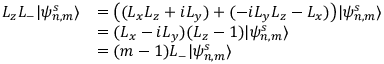<formula> <loc_0><loc_0><loc_500><loc_500>\begin{array} { r l } { L _ { z } L _ { - } | \psi _ { n , m } ^ { s } \rangle } & { = \left ( ( L _ { x } L _ { z } + i L _ { y } ) + ( - i L _ { y } L _ { z } - L _ { x } ) \right ) | \psi _ { n , m } ^ { s } \rangle } \\ & { = ( L _ { x } - i L _ { y } ) ( L _ { z } - 1 ) | \psi _ { n , m } ^ { s } \rangle } \\ & { = ( m - 1 ) L _ { - } | \psi _ { n , m } ^ { s } \rangle } \end{array}</formula> 